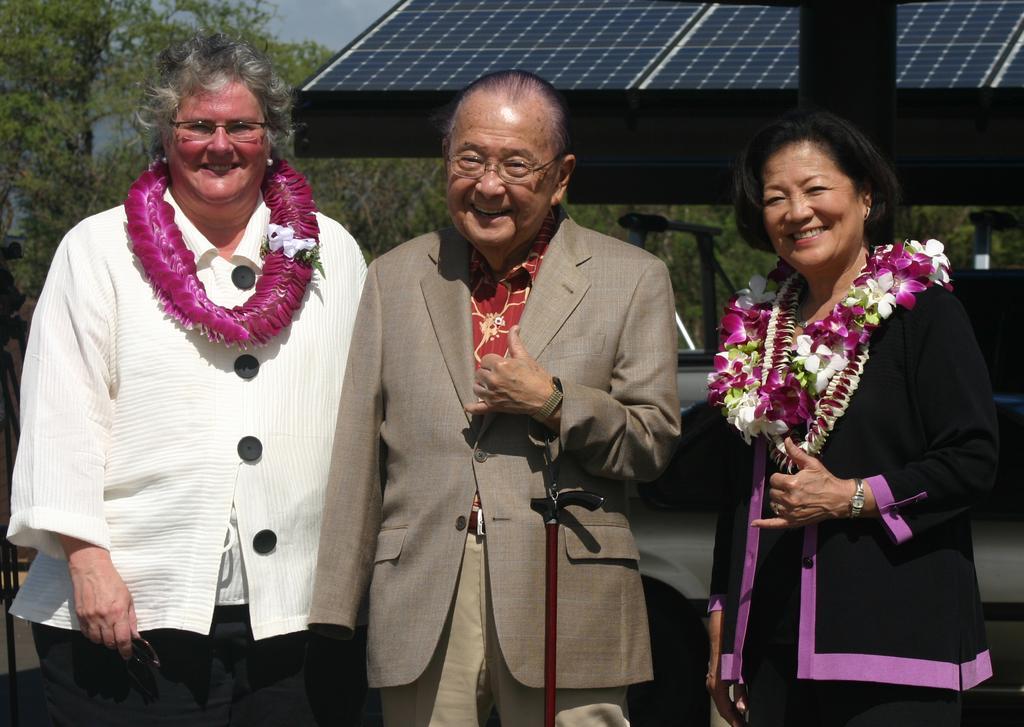Can you describe this image briefly? In the picture I can see a woman wearing a black dress and flower garland is on the left side of the image and a woman wearing a white dress and flower garden is standing on the left side of the image and here we can see a person wearing a blazer and spectacles is standing in the center of the image. In the background, we can see trees, houses and the sky. 